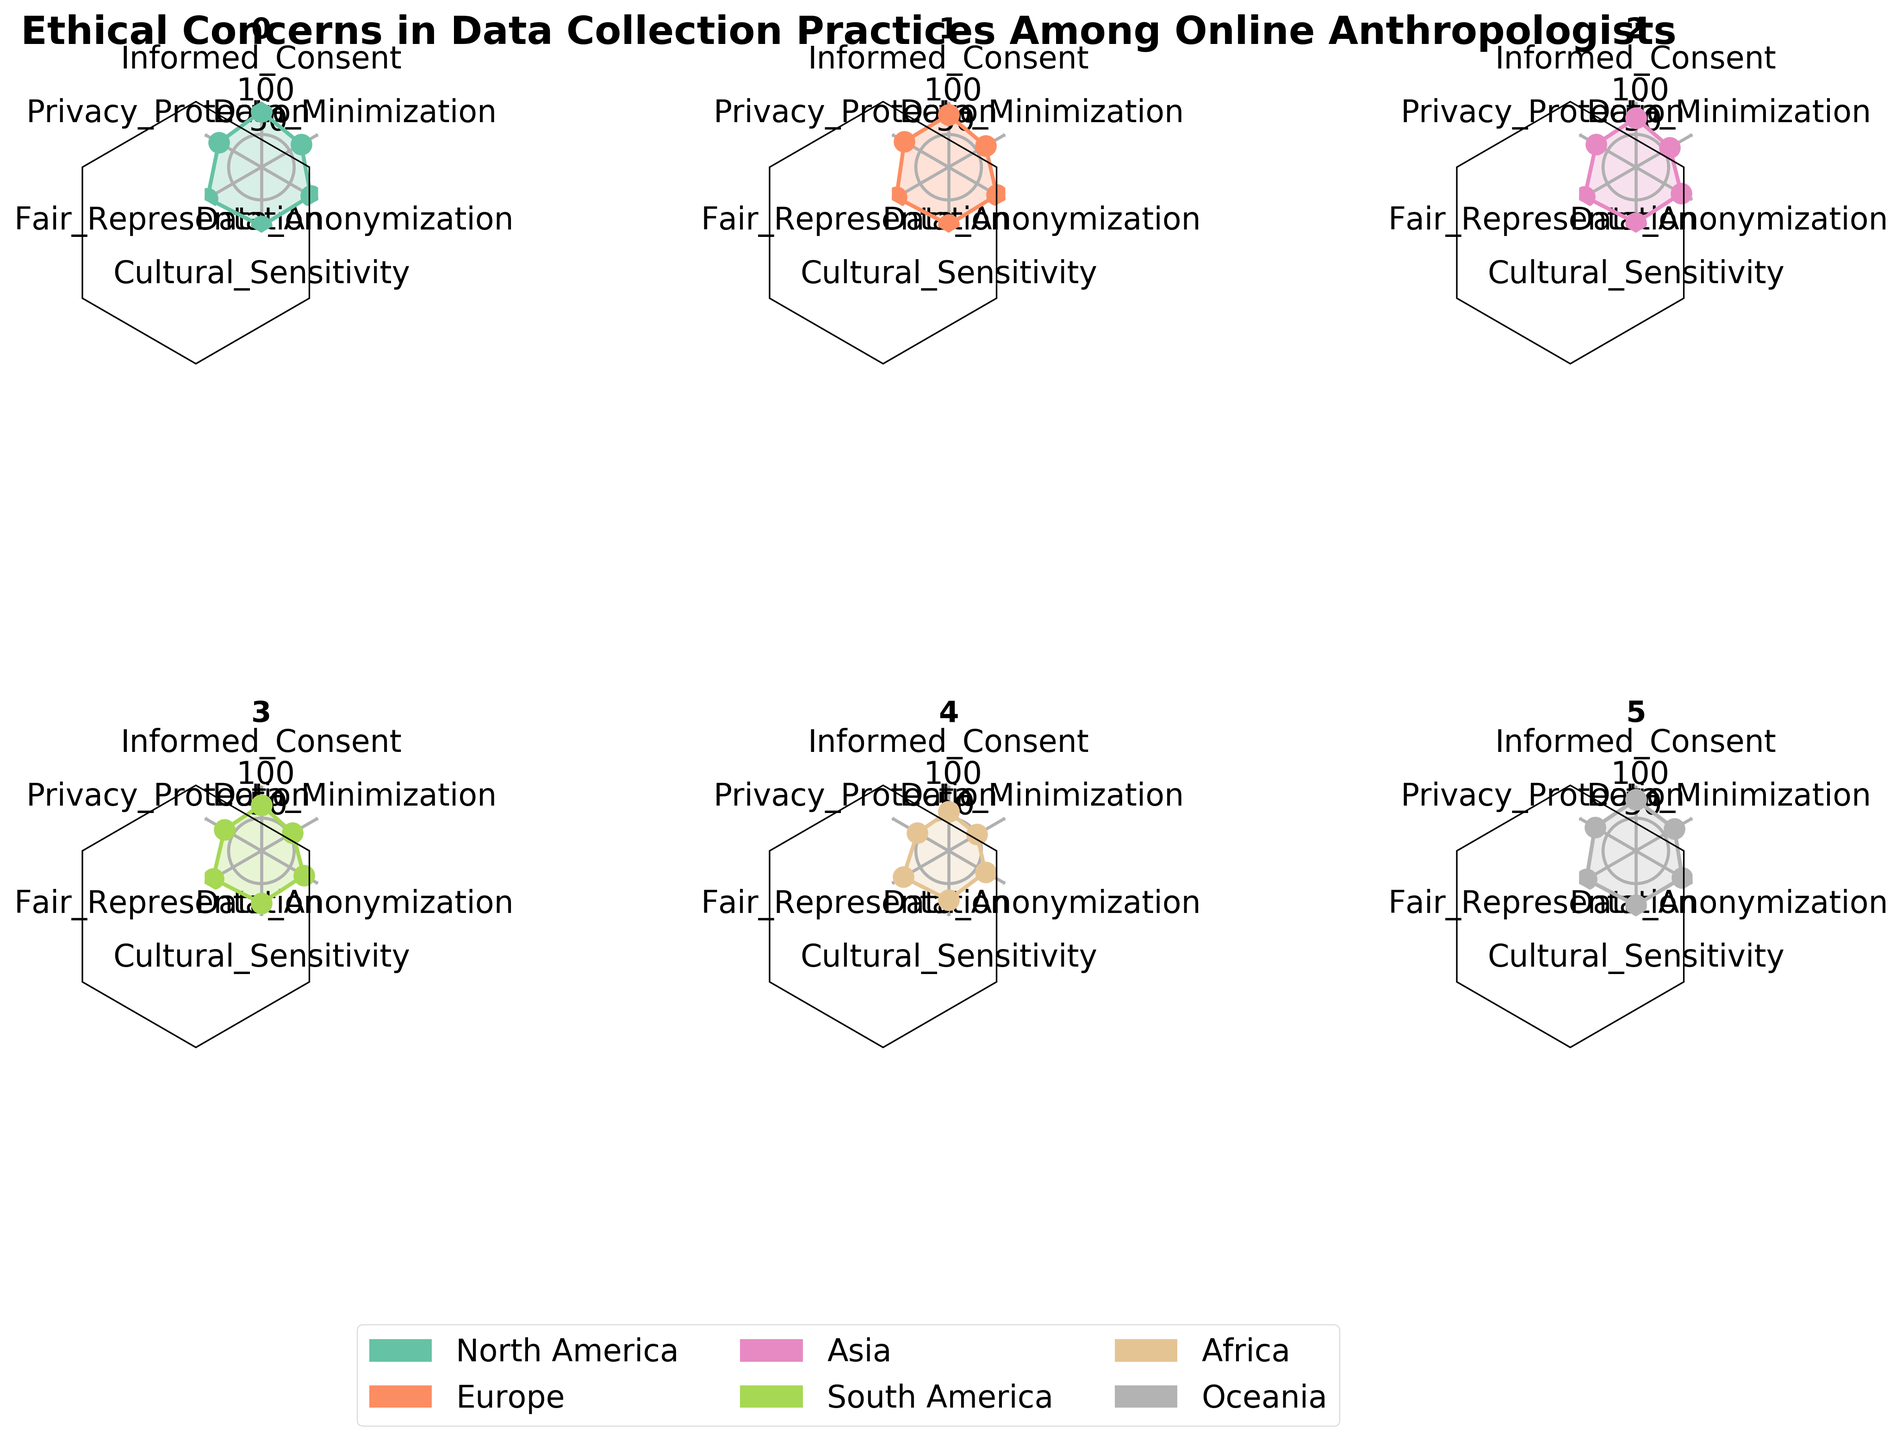What is the title of the radar chart? The title is prominently displayed at the top of the figure. It reads "Ethical Concerns in Data Collection Practices Among Online Anthropologists."
Answer: Ethical Concerns in Data Collection Practices Among Online Anthropologists Which region shows the highest value for Informed Consent? On the radar chart for each region, look for the section labeled "Informed Consent." North America reaches the highest point on this axis.
Answer: North America Which regions have a Data Anonymization value above 80? Check the Data Anonymization axis for each subplot. North America, Europe, and Oceania all have values above 80.
Answer: North America, Europe, Oceania What is the average Privacy Protection score among all the regions? Sum all the Privacy Protection scores from the data and divide by the number of regions. (75 + 78 + 70 + 65 + 55 + 72) / 6 = 69.17
Answer: 69.17 Which region has the lowest score in Data Minimization? Locate the score for Data Minimization on each radar chart. Africa has the lowest score with 50.
Answer: Africa How does the Cultural Sensitivity score of Asia compare to that of South America? Compare the Cultural Sensitivity scores from both regions. Asia has 85, while South America has 80.
Answer: Asia is higher Which ethical concern has the most consistent value across all regions? Observe the radar charts to see which axis has similar lengths for all regions. Cultural Sensitivity appears to be the most consistent among regions.
Answer: Cultural Sensitivity How many ethical concerns are represented in each subplot of the radar chart? Count the number of axes or sections in any of the radar charts, which represent the ethical concerns. There are 6 ethical concerns.
Answer: 6 